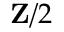Convert formula to latex. <formula><loc_0><loc_0><loc_500><loc_500>Z / 2</formula> 